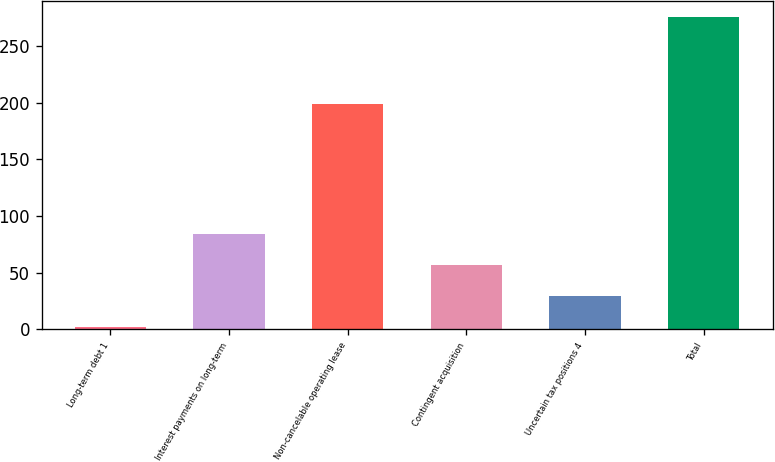Convert chart. <chart><loc_0><loc_0><loc_500><loc_500><bar_chart><fcel>Long-term debt 1<fcel>Interest payments on long-term<fcel>Non-cancelable operating lease<fcel>Contingent acquisition<fcel>Uncertain tax positions 4<fcel>Total<nl><fcel>2<fcel>84.14<fcel>198.9<fcel>56.76<fcel>29.38<fcel>275.8<nl></chart> 